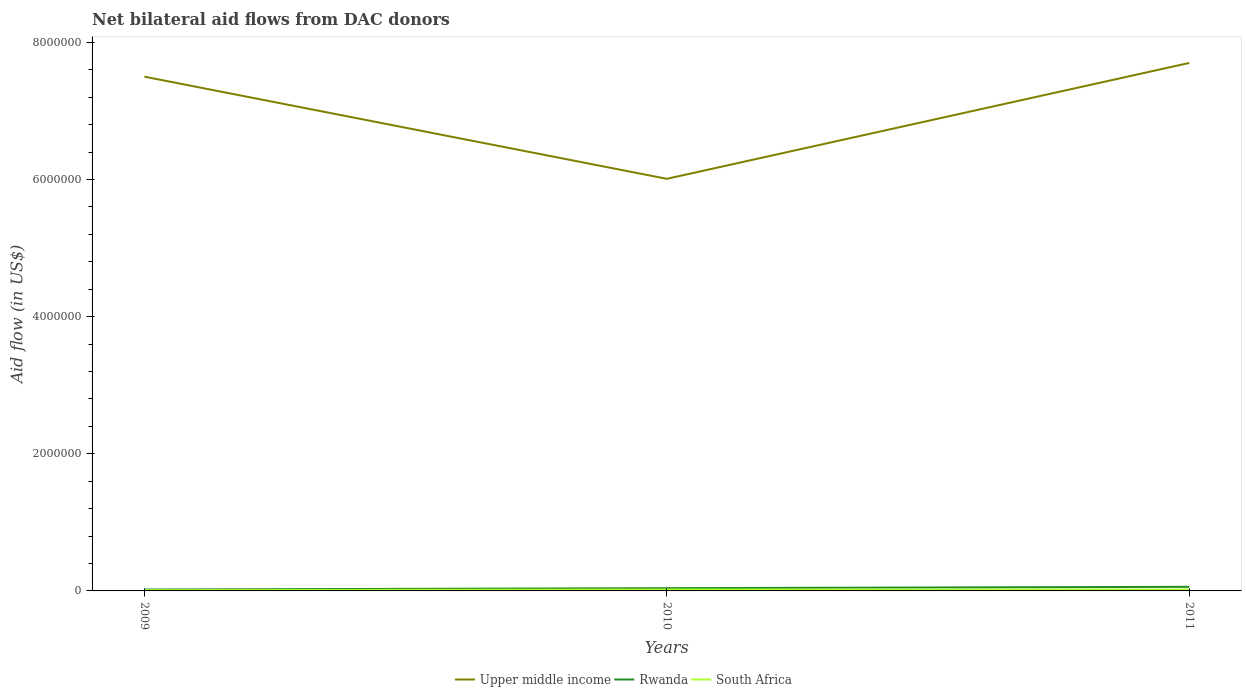How many different coloured lines are there?
Your answer should be compact. 3. Does the line corresponding to Upper middle income intersect with the line corresponding to Rwanda?
Your answer should be compact. No. Across all years, what is the maximum net bilateral aid flow in Upper middle income?
Keep it short and to the point. 6.01e+06. In which year was the net bilateral aid flow in South Africa maximum?
Keep it short and to the point. 2009. What is the difference between the highest and the second highest net bilateral aid flow in Upper middle income?
Your response must be concise. 1.69e+06. Is the net bilateral aid flow in South Africa strictly greater than the net bilateral aid flow in Rwanda over the years?
Your answer should be very brief. Yes. How many lines are there?
Your answer should be compact. 3. How many years are there in the graph?
Your answer should be compact. 3. Are the values on the major ticks of Y-axis written in scientific E-notation?
Your response must be concise. No. Does the graph contain grids?
Ensure brevity in your answer.  No. What is the title of the graph?
Offer a terse response. Net bilateral aid flows from DAC donors. What is the label or title of the X-axis?
Ensure brevity in your answer.  Years. What is the label or title of the Y-axis?
Keep it short and to the point. Aid flow (in US$). What is the Aid flow (in US$) of Upper middle income in 2009?
Provide a short and direct response. 7.50e+06. What is the Aid flow (in US$) in Upper middle income in 2010?
Keep it short and to the point. 6.01e+06. What is the Aid flow (in US$) of South Africa in 2010?
Keep it short and to the point. 2.00e+04. What is the Aid flow (in US$) of Upper middle income in 2011?
Offer a terse response. 7.70e+06. What is the Aid flow (in US$) of Rwanda in 2011?
Your response must be concise. 6.00e+04. What is the Aid flow (in US$) of South Africa in 2011?
Keep it short and to the point. 2.00e+04. Across all years, what is the maximum Aid flow (in US$) of Upper middle income?
Keep it short and to the point. 7.70e+06. Across all years, what is the maximum Aid flow (in US$) in Rwanda?
Make the answer very short. 6.00e+04. Across all years, what is the minimum Aid flow (in US$) in Upper middle income?
Make the answer very short. 6.01e+06. What is the total Aid flow (in US$) of Upper middle income in the graph?
Keep it short and to the point. 2.12e+07. What is the total Aid flow (in US$) in South Africa in the graph?
Offer a terse response. 5.00e+04. What is the difference between the Aid flow (in US$) in Upper middle income in 2009 and that in 2010?
Ensure brevity in your answer.  1.49e+06. What is the difference between the Aid flow (in US$) of Rwanda in 2009 and that in 2010?
Give a very brief answer. -2.00e+04. What is the difference between the Aid flow (in US$) in South Africa in 2009 and that in 2010?
Give a very brief answer. -10000. What is the difference between the Aid flow (in US$) of Upper middle income in 2009 and that in 2011?
Provide a short and direct response. -2.00e+05. What is the difference between the Aid flow (in US$) in South Africa in 2009 and that in 2011?
Provide a succinct answer. -10000. What is the difference between the Aid flow (in US$) in Upper middle income in 2010 and that in 2011?
Keep it short and to the point. -1.69e+06. What is the difference between the Aid flow (in US$) in Rwanda in 2010 and that in 2011?
Offer a terse response. -2.00e+04. What is the difference between the Aid flow (in US$) of South Africa in 2010 and that in 2011?
Your response must be concise. 0. What is the difference between the Aid flow (in US$) in Upper middle income in 2009 and the Aid flow (in US$) in Rwanda in 2010?
Keep it short and to the point. 7.46e+06. What is the difference between the Aid flow (in US$) in Upper middle income in 2009 and the Aid flow (in US$) in South Africa in 2010?
Your answer should be very brief. 7.48e+06. What is the difference between the Aid flow (in US$) of Upper middle income in 2009 and the Aid flow (in US$) of Rwanda in 2011?
Your answer should be very brief. 7.44e+06. What is the difference between the Aid flow (in US$) of Upper middle income in 2009 and the Aid flow (in US$) of South Africa in 2011?
Offer a terse response. 7.48e+06. What is the difference between the Aid flow (in US$) of Rwanda in 2009 and the Aid flow (in US$) of South Africa in 2011?
Make the answer very short. 0. What is the difference between the Aid flow (in US$) in Upper middle income in 2010 and the Aid flow (in US$) in Rwanda in 2011?
Your answer should be very brief. 5.95e+06. What is the difference between the Aid flow (in US$) in Upper middle income in 2010 and the Aid flow (in US$) in South Africa in 2011?
Provide a short and direct response. 5.99e+06. What is the difference between the Aid flow (in US$) of Rwanda in 2010 and the Aid flow (in US$) of South Africa in 2011?
Make the answer very short. 2.00e+04. What is the average Aid flow (in US$) of Upper middle income per year?
Offer a very short reply. 7.07e+06. What is the average Aid flow (in US$) in Rwanda per year?
Give a very brief answer. 4.00e+04. What is the average Aid flow (in US$) in South Africa per year?
Offer a very short reply. 1.67e+04. In the year 2009, what is the difference between the Aid flow (in US$) in Upper middle income and Aid flow (in US$) in Rwanda?
Keep it short and to the point. 7.48e+06. In the year 2009, what is the difference between the Aid flow (in US$) of Upper middle income and Aid flow (in US$) of South Africa?
Your answer should be very brief. 7.49e+06. In the year 2009, what is the difference between the Aid flow (in US$) in Rwanda and Aid flow (in US$) in South Africa?
Provide a succinct answer. 10000. In the year 2010, what is the difference between the Aid flow (in US$) of Upper middle income and Aid flow (in US$) of Rwanda?
Offer a terse response. 5.97e+06. In the year 2010, what is the difference between the Aid flow (in US$) of Upper middle income and Aid flow (in US$) of South Africa?
Offer a terse response. 5.99e+06. In the year 2010, what is the difference between the Aid flow (in US$) of Rwanda and Aid flow (in US$) of South Africa?
Make the answer very short. 2.00e+04. In the year 2011, what is the difference between the Aid flow (in US$) in Upper middle income and Aid flow (in US$) in Rwanda?
Offer a terse response. 7.64e+06. In the year 2011, what is the difference between the Aid flow (in US$) in Upper middle income and Aid flow (in US$) in South Africa?
Offer a terse response. 7.68e+06. What is the ratio of the Aid flow (in US$) in Upper middle income in 2009 to that in 2010?
Give a very brief answer. 1.25. What is the ratio of the Aid flow (in US$) of Rwanda in 2009 to that in 2011?
Offer a very short reply. 0.33. What is the ratio of the Aid flow (in US$) in Upper middle income in 2010 to that in 2011?
Make the answer very short. 0.78. What is the ratio of the Aid flow (in US$) in Rwanda in 2010 to that in 2011?
Your answer should be compact. 0.67. What is the difference between the highest and the second highest Aid flow (in US$) in Upper middle income?
Offer a terse response. 2.00e+05. What is the difference between the highest and the second highest Aid flow (in US$) in Rwanda?
Offer a terse response. 2.00e+04. What is the difference between the highest and the second highest Aid flow (in US$) in South Africa?
Provide a short and direct response. 0. What is the difference between the highest and the lowest Aid flow (in US$) in Upper middle income?
Provide a succinct answer. 1.69e+06. What is the difference between the highest and the lowest Aid flow (in US$) of South Africa?
Your answer should be compact. 10000. 